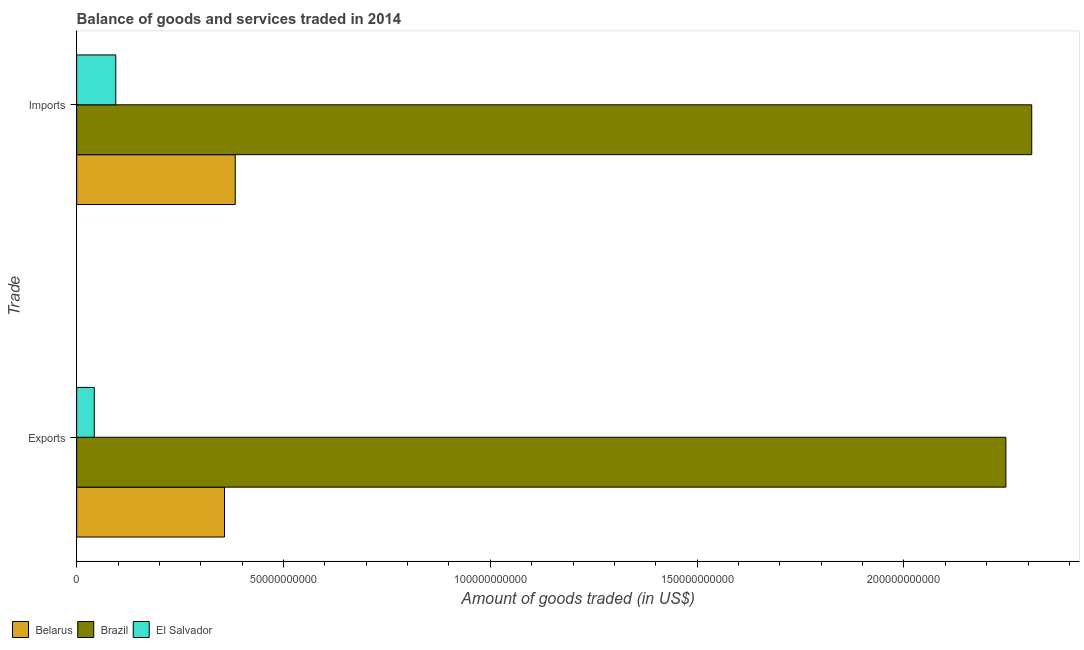How many groups of bars are there?
Your response must be concise. 2. Are the number of bars per tick equal to the number of legend labels?
Your answer should be very brief. Yes. Are the number of bars on each tick of the Y-axis equal?
Your answer should be compact. Yes. What is the label of the 1st group of bars from the top?
Your response must be concise. Imports. What is the amount of goods exported in Brazil?
Keep it short and to the point. 2.25e+11. Across all countries, what is the maximum amount of goods exported?
Give a very brief answer. 2.25e+11. Across all countries, what is the minimum amount of goods exported?
Keep it short and to the point. 4.26e+09. In which country was the amount of goods imported maximum?
Keep it short and to the point. Brazil. In which country was the amount of goods exported minimum?
Offer a terse response. El Salvador. What is the total amount of goods imported in the graph?
Your answer should be compact. 2.79e+11. What is the difference between the amount of goods imported in Belarus and that in Brazil?
Make the answer very short. -1.93e+11. What is the difference between the amount of goods exported in Brazil and the amount of goods imported in Belarus?
Offer a very short reply. 1.86e+11. What is the average amount of goods imported per country?
Provide a succinct answer. 9.29e+1. What is the difference between the amount of goods exported and amount of goods imported in El Salvador?
Offer a terse response. -5.21e+09. What is the ratio of the amount of goods exported in Brazil to that in Belarus?
Your answer should be compact. 6.29. What does the 3rd bar from the top in Exports represents?
Ensure brevity in your answer.  Belarus. What does the 3rd bar from the bottom in Exports represents?
Offer a very short reply. El Salvador. How many bars are there?
Give a very brief answer. 6. Are all the bars in the graph horizontal?
Keep it short and to the point. Yes. What is the difference between two consecutive major ticks on the X-axis?
Offer a terse response. 5.00e+1. Are the values on the major ticks of X-axis written in scientific E-notation?
Your response must be concise. No. Does the graph contain grids?
Give a very brief answer. No. How many legend labels are there?
Provide a succinct answer. 3. How are the legend labels stacked?
Offer a terse response. Horizontal. What is the title of the graph?
Keep it short and to the point. Balance of goods and services traded in 2014. What is the label or title of the X-axis?
Make the answer very short. Amount of goods traded (in US$). What is the label or title of the Y-axis?
Make the answer very short. Trade. What is the Amount of goods traded (in US$) in Belarus in Exports?
Keep it short and to the point. 3.57e+1. What is the Amount of goods traded (in US$) in Brazil in Exports?
Your response must be concise. 2.25e+11. What is the Amount of goods traded (in US$) in El Salvador in Exports?
Offer a terse response. 4.26e+09. What is the Amount of goods traded (in US$) of Belarus in Imports?
Ensure brevity in your answer.  3.83e+1. What is the Amount of goods traded (in US$) of Brazil in Imports?
Your response must be concise. 2.31e+11. What is the Amount of goods traded (in US$) in El Salvador in Imports?
Offer a terse response. 9.46e+09. Across all Trade, what is the maximum Amount of goods traded (in US$) of Belarus?
Make the answer very short. 3.83e+1. Across all Trade, what is the maximum Amount of goods traded (in US$) of Brazil?
Provide a short and direct response. 2.31e+11. Across all Trade, what is the maximum Amount of goods traded (in US$) in El Salvador?
Your answer should be very brief. 9.46e+09. Across all Trade, what is the minimum Amount of goods traded (in US$) in Belarus?
Keep it short and to the point. 3.57e+1. Across all Trade, what is the minimum Amount of goods traded (in US$) in Brazil?
Ensure brevity in your answer.  2.25e+11. Across all Trade, what is the minimum Amount of goods traded (in US$) in El Salvador?
Your answer should be very brief. 4.26e+09. What is the total Amount of goods traded (in US$) of Belarus in the graph?
Give a very brief answer. 7.41e+1. What is the total Amount of goods traded (in US$) of Brazil in the graph?
Provide a short and direct response. 4.56e+11. What is the total Amount of goods traded (in US$) of El Salvador in the graph?
Offer a very short reply. 1.37e+1. What is the difference between the Amount of goods traded (in US$) of Belarus in Exports and that in Imports?
Provide a succinct answer. -2.60e+09. What is the difference between the Amount of goods traded (in US$) in Brazil in Exports and that in Imports?
Provide a short and direct response. -6.25e+09. What is the difference between the Amount of goods traded (in US$) of El Salvador in Exports and that in Imports?
Offer a very short reply. -5.21e+09. What is the difference between the Amount of goods traded (in US$) in Belarus in Exports and the Amount of goods traded (in US$) in Brazil in Imports?
Provide a succinct answer. -1.95e+11. What is the difference between the Amount of goods traded (in US$) of Belarus in Exports and the Amount of goods traded (in US$) of El Salvador in Imports?
Give a very brief answer. 2.63e+1. What is the difference between the Amount of goods traded (in US$) of Brazil in Exports and the Amount of goods traded (in US$) of El Salvador in Imports?
Ensure brevity in your answer.  2.15e+11. What is the average Amount of goods traded (in US$) of Belarus per Trade?
Offer a very short reply. 3.70e+1. What is the average Amount of goods traded (in US$) of Brazil per Trade?
Make the answer very short. 2.28e+11. What is the average Amount of goods traded (in US$) of El Salvador per Trade?
Provide a short and direct response. 6.86e+09. What is the difference between the Amount of goods traded (in US$) of Belarus and Amount of goods traded (in US$) of Brazil in Exports?
Make the answer very short. -1.89e+11. What is the difference between the Amount of goods traded (in US$) of Belarus and Amount of goods traded (in US$) of El Salvador in Exports?
Provide a succinct answer. 3.15e+1. What is the difference between the Amount of goods traded (in US$) in Brazil and Amount of goods traded (in US$) in El Salvador in Exports?
Keep it short and to the point. 2.20e+11. What is the difference between the Amount of goods traded (in US$) in Belarus and Amount of goods traded (in US$) in Brazil in Imports?
Ensure brevity in your answer.  -1.93e+11. What is the difference between the Amount of goods traded (in US$) of Belarus and Amount of goods traded (in US$) of El Salvador in Imports?
Offer a very short reply. 2.89e+1. What is the difference between the Amount of goods traded (in US$) in Brazil and Amount of goods traded (in US$) in El Salvador in Imports?
Provide a succinct answer. 2.21e+11. What is the ratio of the Amount of goods traded (in US$) in Belarus in Exports to that in Imports?
Keep it short and to the point. 0.93. What is the ratio of the Amount of goods traded (in US$) in Brazil in Exports to that in Imports?
Make the answer very short. 0.97. What is the ratio of the Amount of goods traded (in US$) of El Salvador in Exports to that in Imports?
Offer a terse response. 0.45. What is the difference between the highest and the second highest Amount of goods traded (in US$) of Belarus?
Keep it short and to the point. 2.60e+09. What is the difference between the highest and the second highest Amount of goods traded (in US$) of Brazil?
Offer a very short reply. 6.25e+09. What is the difference between the highest and the second highest Amount of goods traded (in US$) in El Salvador?
Offer a terse response. 5.21e+09. What is the difference between the highest and the lowest Amount of goods traded (in US$) of Belarus?
Give a very brief answer. 2.60e+09. What is the difference between the highest and the lowest Amount of goods traded (in US$) of Brazil?
Your response must be concise. 6.25e+09. What is the difference between the highest and the lowest Amount of goods traded (in US$) in El Salvador?
Give a very brief answer. 5.21e+09. 